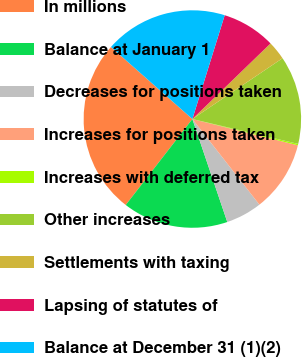Convert chart to OTSL. <chart><loc_0><loc_0><loc_500><loc_500><pie_chart><fcel>In millions<fcel>Balance at January 1<fcel>Decreases for positions taken<fcel>Increases for positions taken<fcel>Increases with deferred tax<fcel>Other increases<fcel>Settlements with taxing<fcel>Lapsing of statutes of<fcel>Balance at December 31 (1)(2)<nl><fcel>26.03%<fcel>15.7%<fcel>5.37%<fcel>10.54%<fcel>0.21%<fcel>13.12%<fcel>2.79%<fcel>7.96%<fcel>18.28%<nl></chart> 